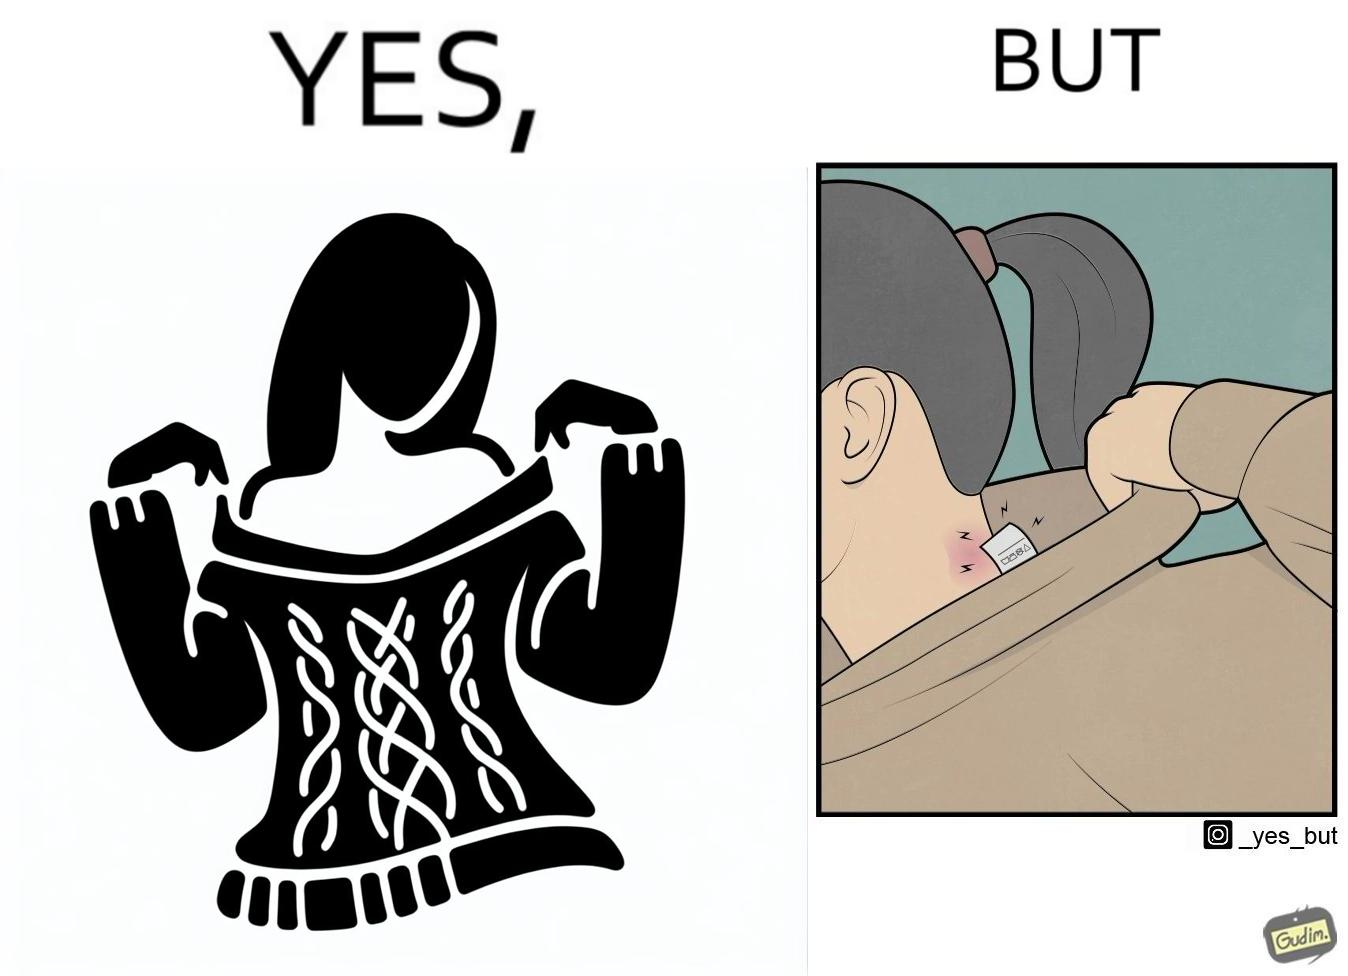Is there satirical content in this image? Yes, this image is satirical. 